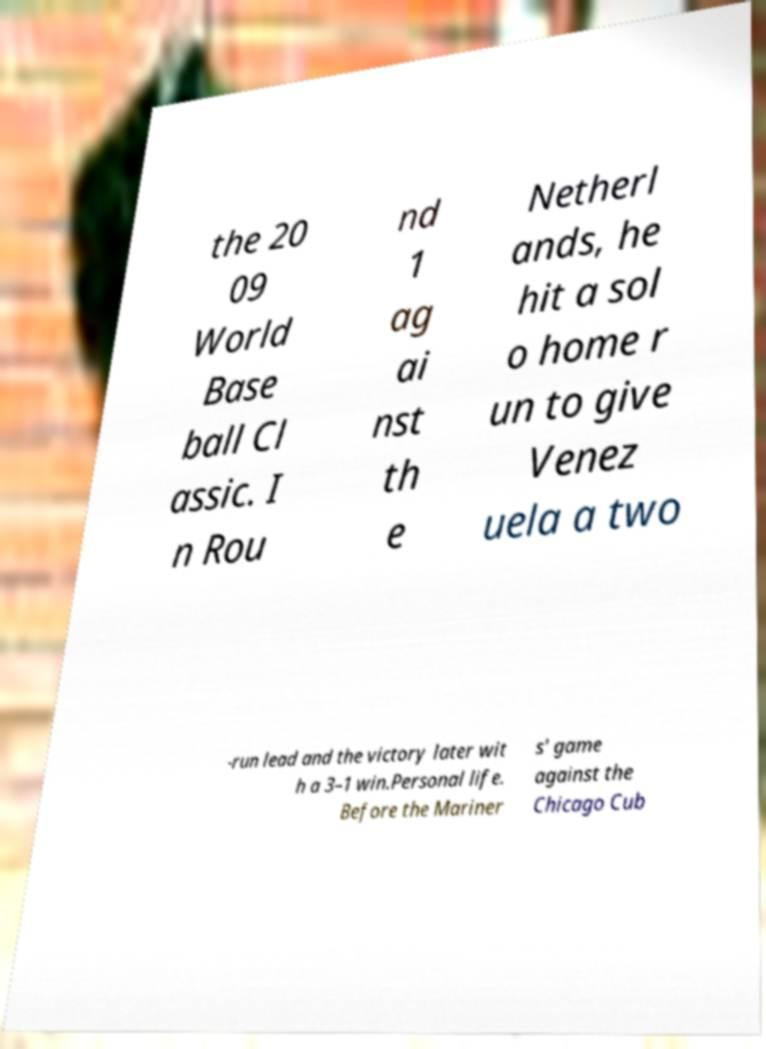I need the written content from this picture converted into text. Can you do that? the 20 09 World Base ball Cl assic. I n Rou nd 1 ag ai nst th e Netherl ands, he hit a sol o home r un to give Venez uela a two -run lead and the victory later wit h a 3–1 win.Personal life. Before the Mariner s' game against the Chicago Cub 